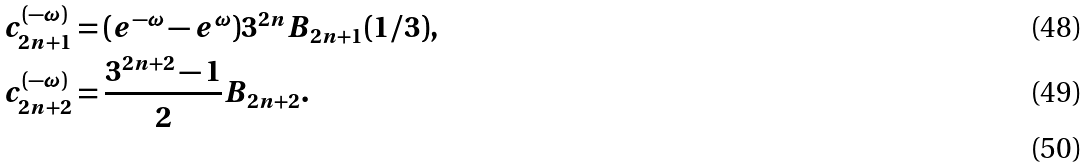<formula> <loc_0><loc_0><loc_500><loc_500>c _ { 2 n + 1 } ^ { ( - \omega ) } & = ( e ^ { - \omega } - e ^ { \omega } ) 3 ^ { 2 n } B _ { 2 n + 1 } ( 1 / 3 ) , \\ c _ { 2 n + 2 } ^ { ( - \omega ) } & = \frac { 3 ^ { 2 n + 2 } - 1 } { 2 } B _ { 2 n + 2 } . \\</formula> 